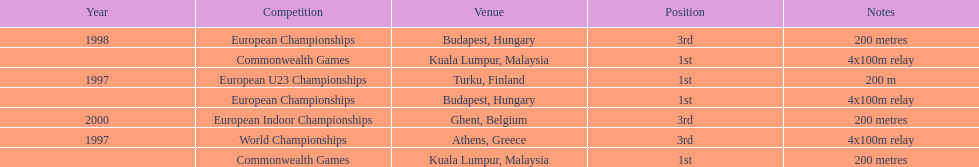How many events were won in malaysia? 2. 